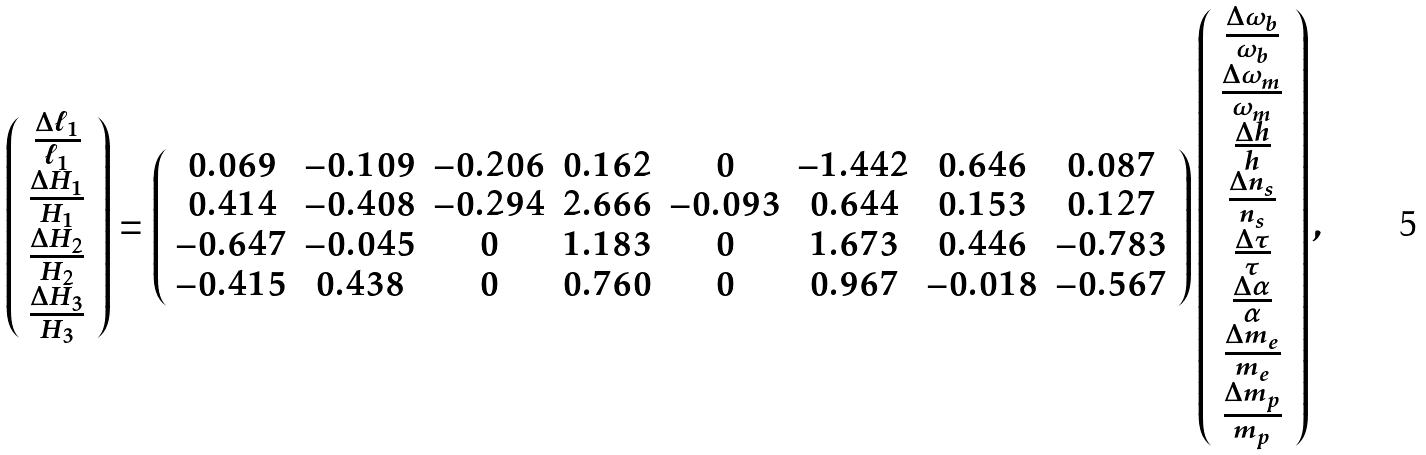Convert formula to latex. <formula><loc_0><loc_0><loc_500><loc_500>\left ( \begin{array} { c } \frac { \Delta \ell _ { 1 } } { \ell _ { 1 } } \\ \frac { \Delta H _ { 1 } } { H _ { 1 } } \\ \frac { \Delta H _ { 2 } } { H _ { 2 } } \\ \frac { \Delta H _ { 3 } } { H _ { 3 } } \end{array} \right ) = \left ( \begin{array} { c c c c c c c c } 0 . 0 6 9 & - 0 . 1 0 9 & - 0 . 2 0 6 & 0 . 1 6 2 & 0 & - 1 . 4 4 2 & 0 . 6 4 6 & 0 . 0 8 7 \\ 0 . 4 1 4 & - 0 . 4 0 8 & - 0 . 2 9 4 & 2 . 6 6 6 & - 0 . 0 9 3 & 0 . 6 4 4 & 0 . 1 5 3 & 0 . 1 2 7 \\ - 0 . 6 4 7 & - 0 . 0 4 5 & 0 & 1 . 1 8 3 & 0 & 1 . 6 7 3 & 0 . 4 4 6 & - 0 . 7 8 3 \\ - 0 . 4 1 5 & 0 . 4 3 8 & 0 & 0 . 7 6 0 & 0 & 0 . 9 6 7 & - 0 . 0 1 8 & - 0 . 5 6 7 \end{array} \right ) \left ( \begin{array} { c } \frac { \Delta \omega _ { b } } { \omega _ { b } } \\ \frac { \Delta \omega _ { m } } { \omega _ { m } } \\ \frac { \Delta h } { h } \\ \frac { \Delta n _ { s } } { n _ { s } } \\ \frac { \Delta \tau } { \tau } \\ \frac { \Delta \alpha } { \alpha } \\ \frac { \Delta m _ { e } } { m _ { e } } \\ \frac { \Delta m _ { p } } { m _ { p } } \\ \end{array} \right ) ,</formula> 